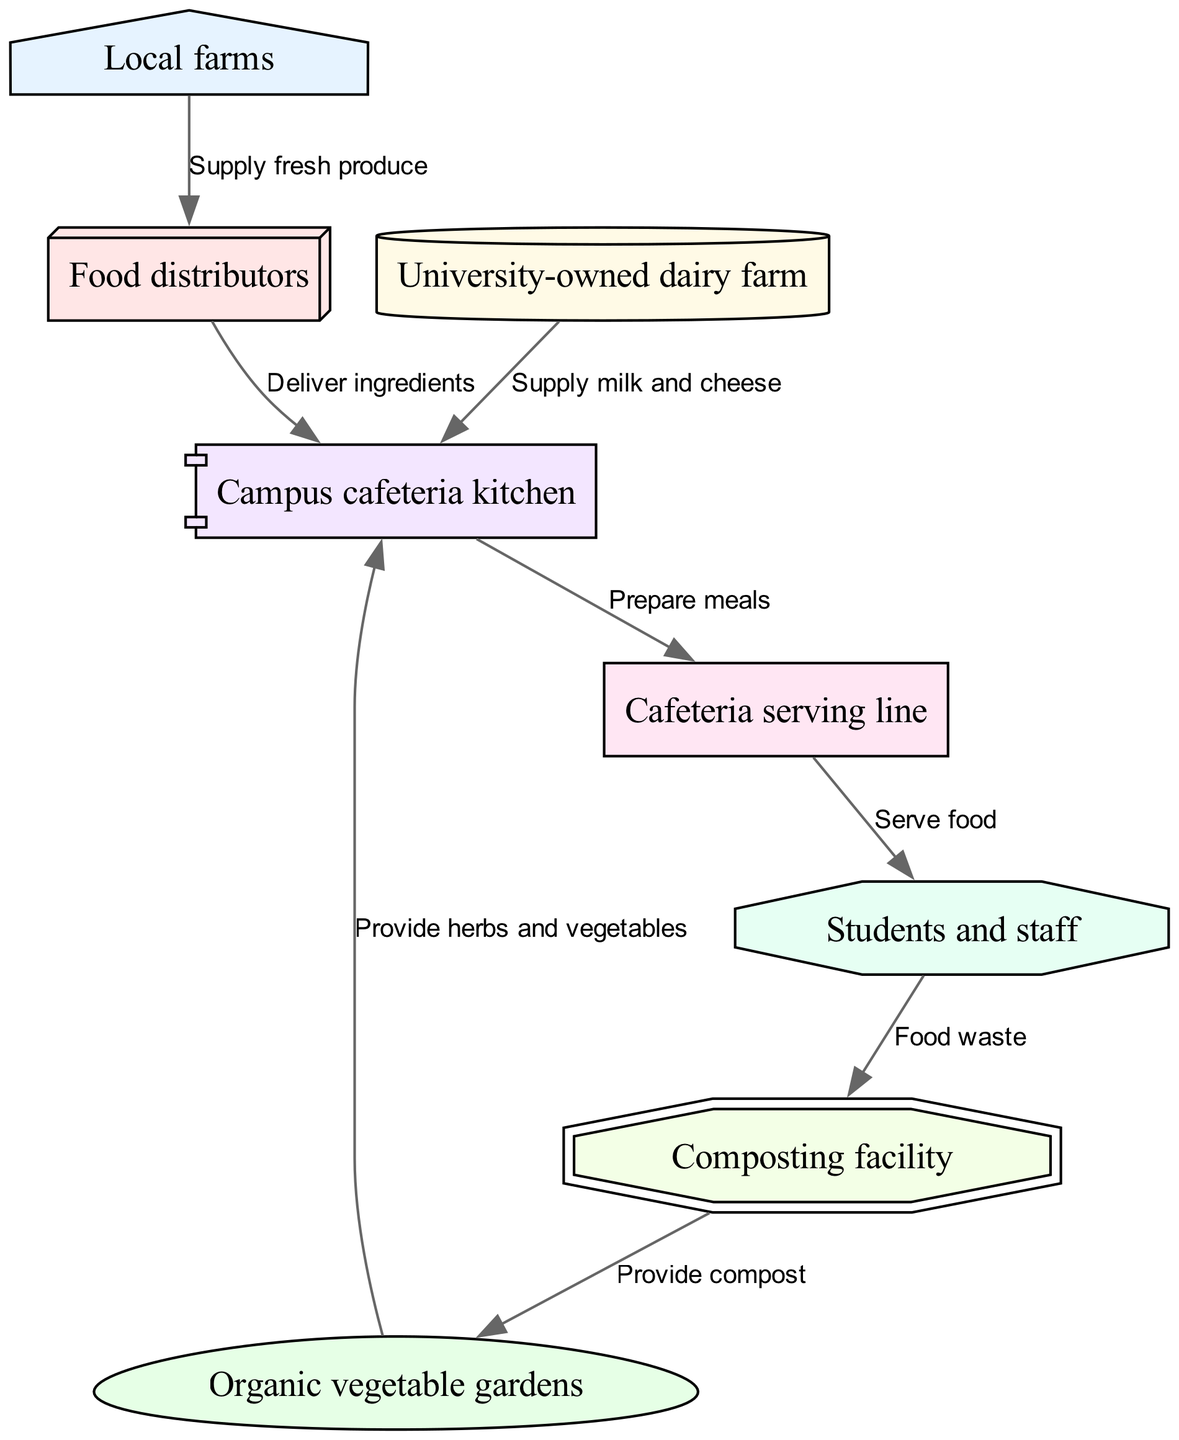What is the total number of nodes in the diagram? In the diagram, the nodes represent different stages of the food chain. Counting each unique node listed, we find there are eight nodes in total: Local farms, Organic vegetable gardens, University-owned dairy farm, Food distributors, Campus cafeteria kitchen, Cafeteria serving line, Students and staff, and Composting facility.
Answer: 8 Who supplies milk and cheese? According to the diagram, the University-owned dairy farm is directly connected to the Campus cafeteria kitchen with the label 'Supply milk and cheese,' indicating that it is the source of these products.
Answer: University-owned dairy farm What serves food to students and staff? The diagram indicates that food flows from the Cafeteria serving line to Students and staff, clearly labeling this connection with 'Serve food,' which defines the serving function of that node.
Answer: Cafeteria serving line How do organic vegetable gardens contribute to the cafeteria? The connection from Organic vegetable gardens to Campus cafeteria kitchen labeled 'Provide herbs and vegetables' shows that they contribute directly by supplying these items for meal preparation in the cafeteria.
Answer: Provide herbs and vegetables What happens to food waste from students and staff? The diagram depicts a flow from Students and staff to Composting facility labeled 'Food waste,' indicating that any leftover or uneaten food is directed to composting, thereby illustrating an efficient waste management process in the food chain.
Answer: Food waste Which two nodes provide direct ingredients to the campus cafeteria kitchen? The edges leading to the Campus cafeteria kitchen come from both Food distributors and University-owned dairy farm, bringing different types of supplies. This can be deduced by checking the connections leading into the kitchen.
Answer: Food distributors, University-owned dairy farm What is provided from the composting facility? The flow from Composting facility to Organic vegetable gardens is labeled 'Provide compost,' indicating that the compost produced from food waste is returned as a nutrient source for the gardens, enhancing sustainability in the food cycle.
Answer: Provide compost How many direct connections does the Campus cafeteria kitchen have? The Campus cafeteria kitchen has three inward connections: one from Food distributors, one from University-owned dairy farm, and one from Organic vegetable gardens, leading to a total of three incoming edges representing different ingredient sources.
Answer: 3 What type of facility is the composting facility classified as in the diagram? The diagram shows the Composting facility represented as a doubleoctagon shape, which is a specific style denoting its role as a facility focusing on recycling and sustainability within the food chain.
Answer: Composting facility 